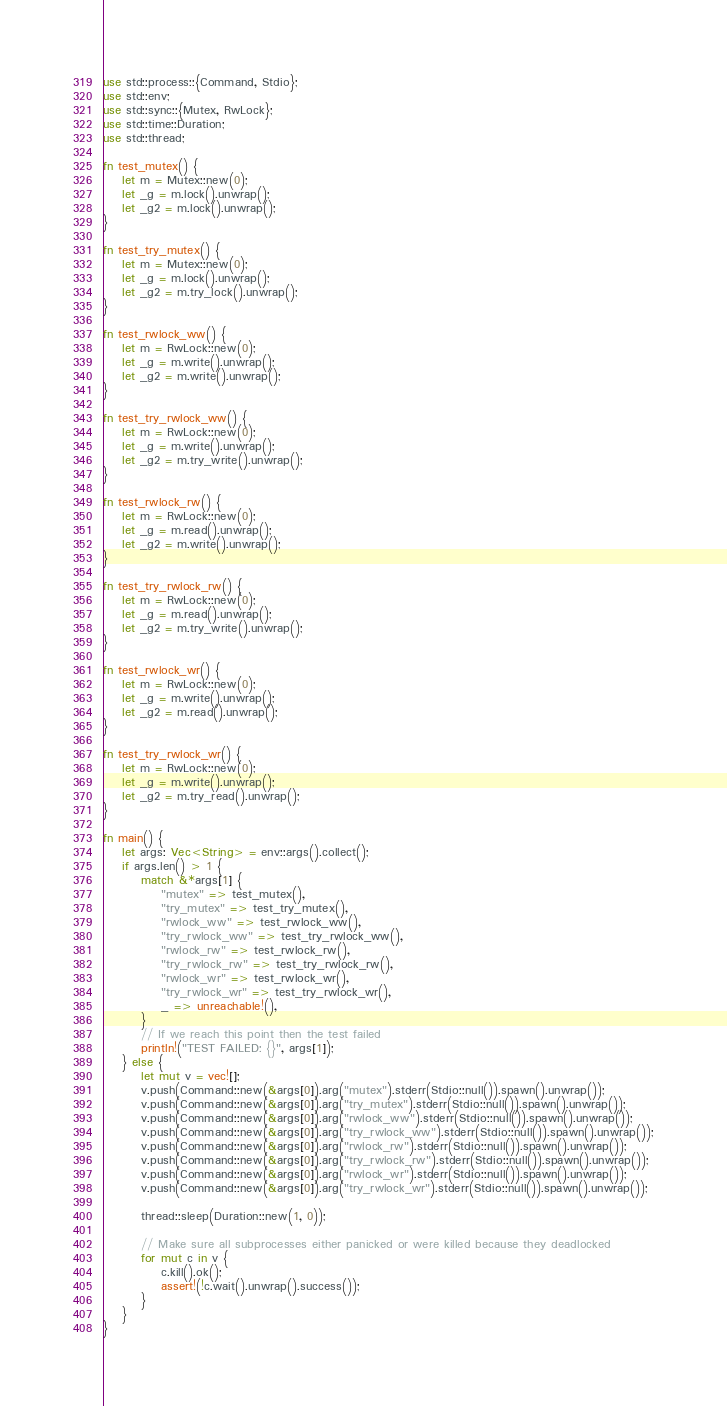Convert code to text. <code><loc_0><loc_0><loc_500><loc_500><_Rust_>use std::process::{Command, Stdio};
use std::env;
use std::sync::{Mutex, RwLock};
use std::time::Duration;
use std::thread;

fn test_mutex() {
    let m = Mutex::new(0);
    let _g = m.lock().unwrap();
    let _g2 = m.lock().unwrap();
}

fn test_try_mutex() {
    let m = Mutex::new(0);
    let _g = m.lock().unwrap();
    let _g2 = m.try_lock().unwrap();
}

fn test_rwlock_ww() {
    let m = RwLock::new(0);
    let _g = m.write().unwrap();
    let _g2 = m.write().unwrap();
}

fn test_try_rwlock_ww() {
    let m = RwLock::new(0);
    let _g = m.write().unwrap();
    let _g2 = m.try_write().unwrap();
}

fn test_rwlock_rw() {
    let m = RwLock::new(0);
    let _g = m.read().unwrap();
    let _g2 = m.write().unwrap();
}

fn test_try_rwlock_rw() {
    let m = RwLock::new(0);
    let _g = m.read().unwrap();
    let _g2 = m.try_write().unwrap();
}

fn test_rwlock_wr() {
    let m = RwLock::new(0);
    let _g = m.write().unwrap();
    let _g2 = m.read().unwrap();
}

fn test_try_rwlock_wr() {
    let m = RwLock::new(0);
    let _g = m.write().unwrap();
    let _g2 = m.try_read().unwrap();
}

fn main() {
    let args: Vec<String> = env::args().collect();
    if args.len() > 1 {
        match &*args[1] {
            "mutex" => test_mutex(),
            "try_mutex" => test_try_mutex(),
            "rwlock_ww" => test_rwlock_ww(),
            "try_rwlock_ww" => test_try_rwlock_ww(),
            "rwlock_rw" => test_rwlock_rw(),
            "try_rwlock_rw" => test_try_rwlock_rw(),
            "rwlock_wr" => test_rwlock_wr(),
            "try_rwlock_wr" => test_try_rwlock_wr(),
            _ => unreachable!(),
        }
        // If we reach this point then the test failed
        println!("TEST FAILED: {}", args[1]);
    } else {
        let mut v = vec![];
        v.push(Command::new(&args[0]).arg("mutex").stderr(Stdio::null()).spawn().unwrap());
        v.push(Command::new(&args[0]).arg("try_mutex").stderr(Stdio::null()).spawn().unwrap());
        v.push(Command::new(&args[0]).arg("rwlock_ww").stderr(Stdio::null()).spawn().unwrap());
        v.push(Command::new(&args[0]).arg("try_rwlock_ww").stderr(Stdio::null()).spawn().unwrap());
        v.push(Command::new(&args[0]).arg("rwlock_rw").stderr(Stdio::null()).spawn().unwrap());
        v.push(Command::new(&args[0]).arg("try_rwlock_rw").stderr(Stdio::null()).spawn().unwrap());
        v.push(Command::new(&args[0]).arg("rwlock_wr").stderr(Stdio::null()).spawn().unwrap());
        v.push(Command::new(&args[0]).arg("try_rwlock_wr").stderr(Stdio::null()).spawn().unwrap());

        thread::sleep(Duration::new(1, 0));

        // Make sure all subprocesses either panicked or were killed because they deadlocked
        for mut c in v {
            c.kill().ok();
            assert!(!c.wait().unwrap().success());
        }
    }
}
</code> 